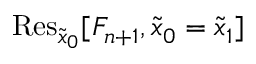<formula> <loc_0><loc_0><loc_500><loc_500>R e s _ { \tilde { x } _ { 0 } } [ F _ { n + 1 } , \tilde { x } _ { 0 } = \tilde { x } _ { 1 } ]</formula> 